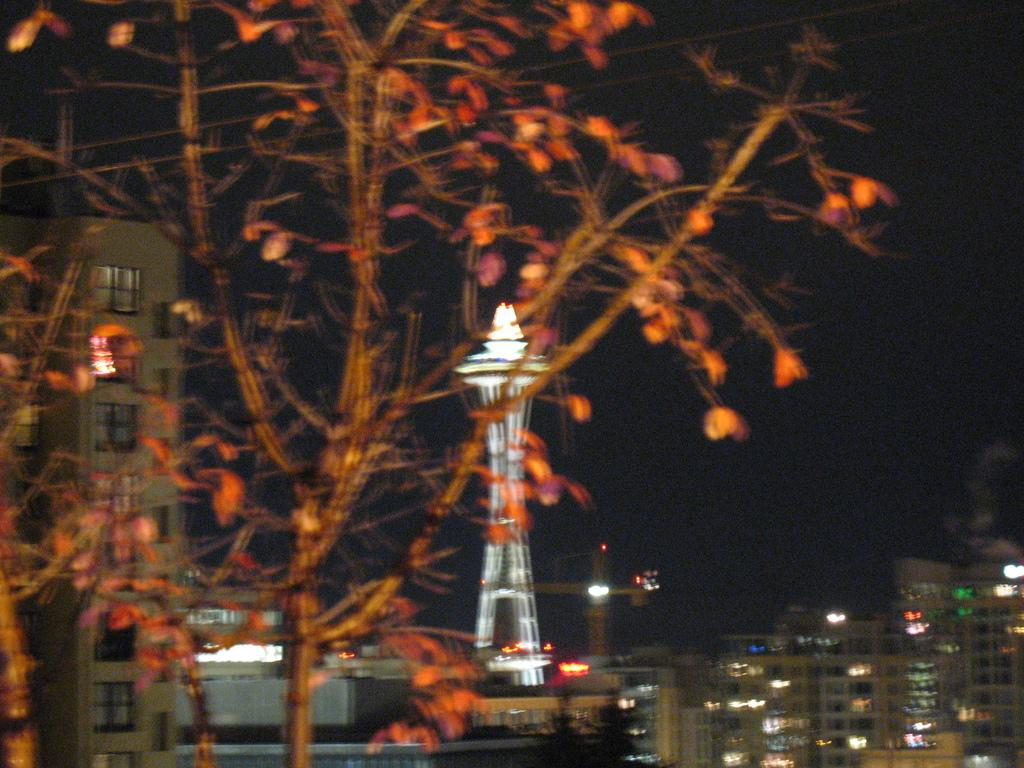What type of natural element is present in the image? There is a tree in the image. What type of man-made structures are present in the image? There are buildings in the image. What time of day is depicted in the image? The image is set at night. What feature of the buildings is visible in the image? The buildings have lights on. What type of tooth is visible in the image? There is no tooth present in the image. What type of juice is being served in the image? There is no juice present in the image. 